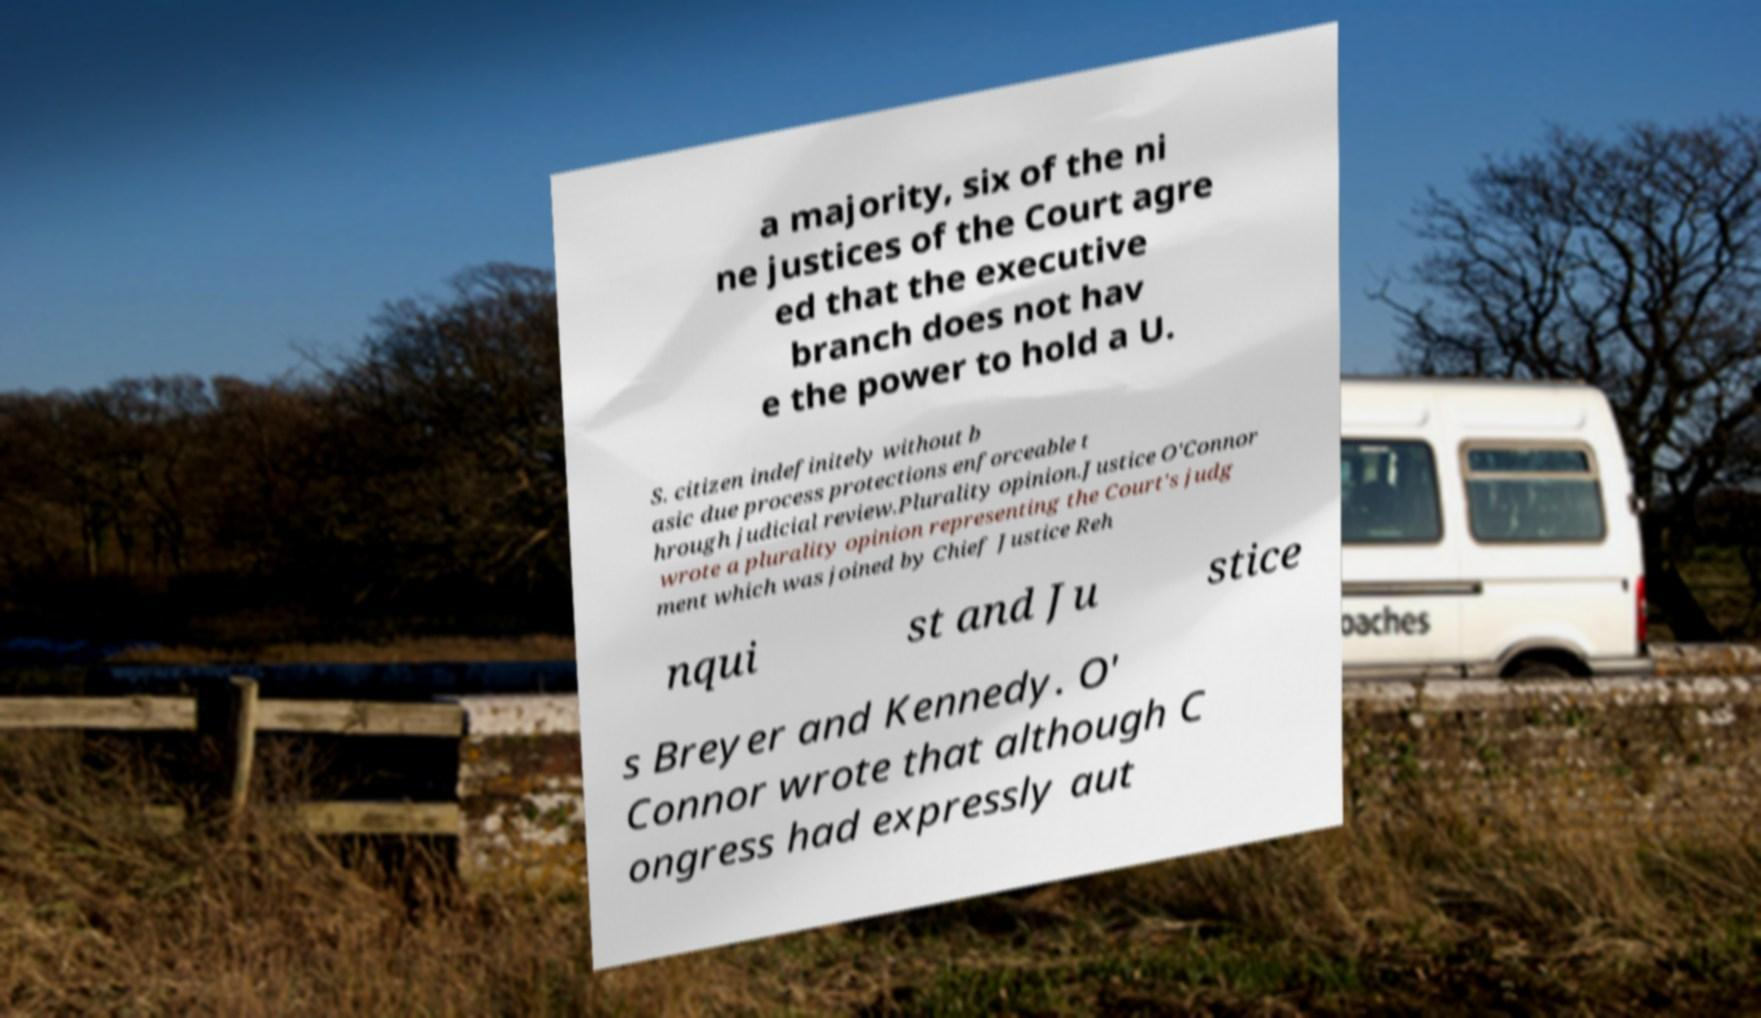I need the written content from this picture converted into text. Can you do that? a majority, six of the ni ne justices of the Court agre ed that the executive branch does not hav e the power to hold a U. S. citizen indefinitely without b asic due process protections enforceable t hrough judicial review.Plurality opinion.Justice O'Connor wrote a plurality opinion representing the Court's judg ment which was joined by Chief Justice Reh nqui st and Ju stice s Breyer and Kennedy. O' Connor wrote that although C ongress had expressly aut 